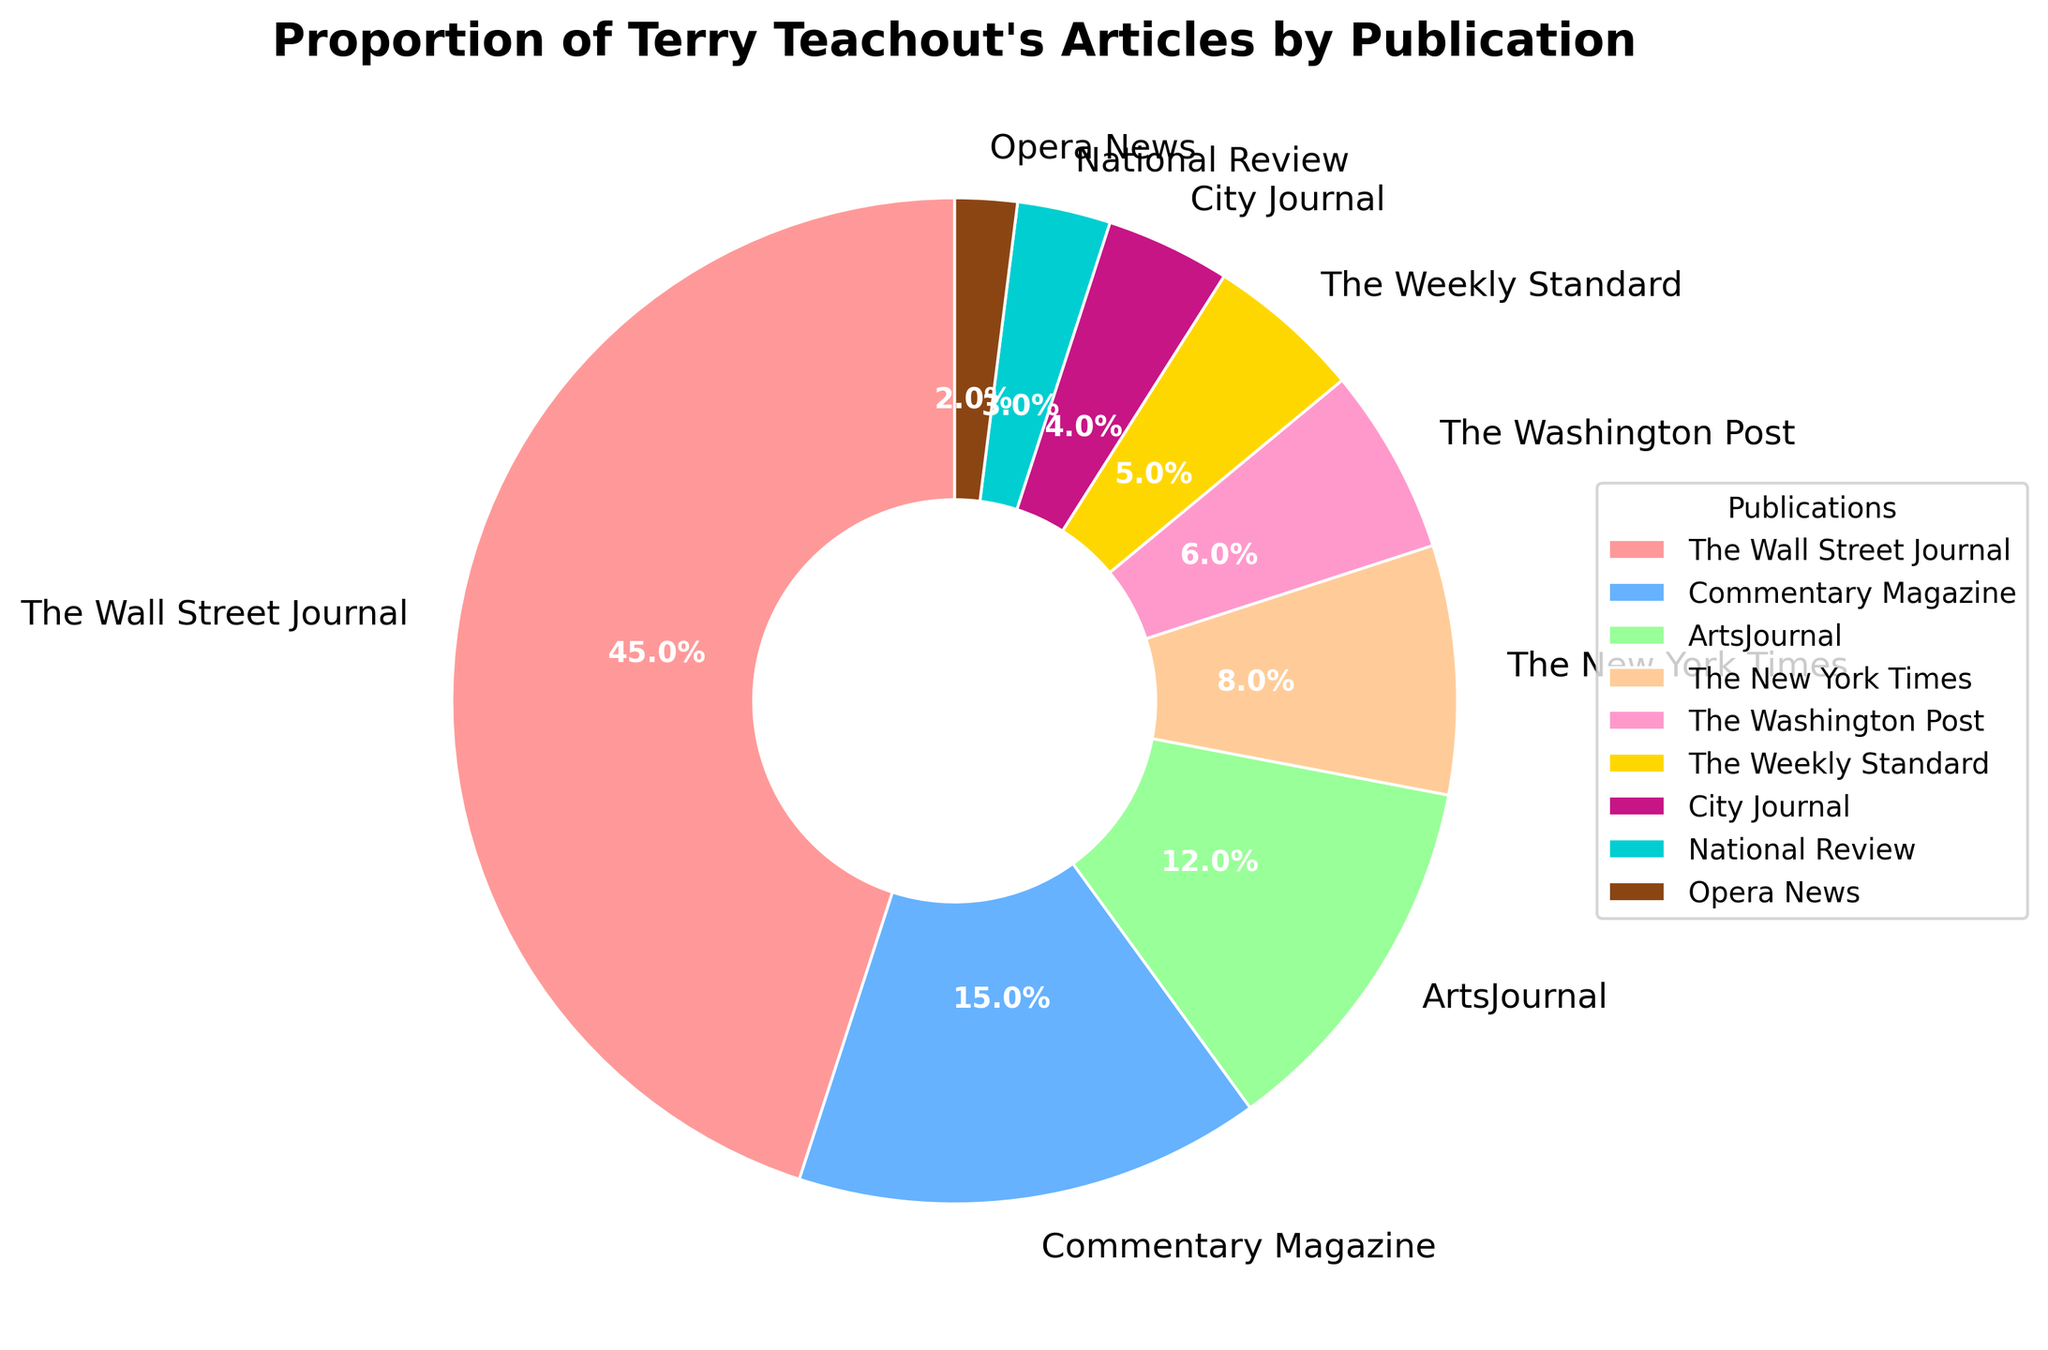Which publication has the highest proportion of Terry Teachout's articles? The publication labeled with the highest percentage slice in the pie chart represents the publication with the highest proportion. In this case, it is The Wall Street Journal with 45%.
Answer: The Wall Street Journal Which two publications together make up more than half of the articles? By summing the proportions of different publications, we find that The Wall Street Journal (45%) and Commentary Magazine (15%) together contribute 60%, which is more than half.
Answer: The Wall Street Journal and Commentary Magazine Arrange publications in descending order of the proportion of articles published. The pie chart segments labeled in descending order of their percentages are: The Wall Street Journal (45%), Commentary Magazine (15%), ArtsJournal (12%), The New York Times (8%), The Washington Post (6%), The Weekly Standard (5%), City Journal (4%), National Review (3%), and Opera News (2%).
Answer: 1. The Wall Street Journal, 2. Commentary Magazine, 3. ArtsJournal, 4. The New York Times, 5. The Washington Post, 6. The Weekly Standard, 7. City Journal, 8. National Review, 9. Opera News What is the proportion of articles published in ArtsJournal compared to City Journal? The pie chart shows percentages for ArtsJournal (12%) and City Journal (4%). The ratio of proportions would be 12% / 4% = 3. Therefore, ArtsJournal has 3 times the proportion of articles compared to City Journal.
Answer: 3 times How much more is the proportion of articles published in The New York Times than in The Weekly Standard? The proportion for The New York Times is 8%, and for The Weekly Standard is 5%. The difference is calculated as 8% - 5% = 3%.
Answer: 3% What is the total proportion of articles published in The Weekly Standard, City Journal, and National Review? Summing the proportions for The Weekly Standard (5%), City Journal (4%), and National Review (3%) gives the total proportion: 5% + 4% + 3% = 12%.
Answer: 12% Which publication(s) have a proportion of articles equal to or less than 5%? The publications with slices showing 5% or less are The Weekly Standard (5%), City Journal (4%), National Review (3%), and Opera News (2%).
Answer: The Weekly Standard, City Journal, National Review, Opera News If we combined the proportion of articles from The New York Times and The Washington Post, would it exceed the proportion for Commentary Magazine? The New York Times (8%) and The Washington Post (6%) together make 14%, which is less than Commentary Magazine's 15%.
Answer: No Which color represents The Wall Street Journal in the pie chart? Though exact colors are not visible here, the largest section of the pie chart representing The Wall Street Journal should be prominently distinguished, typically in the first listed color, which seems to be the red slice.
Answer: Red 